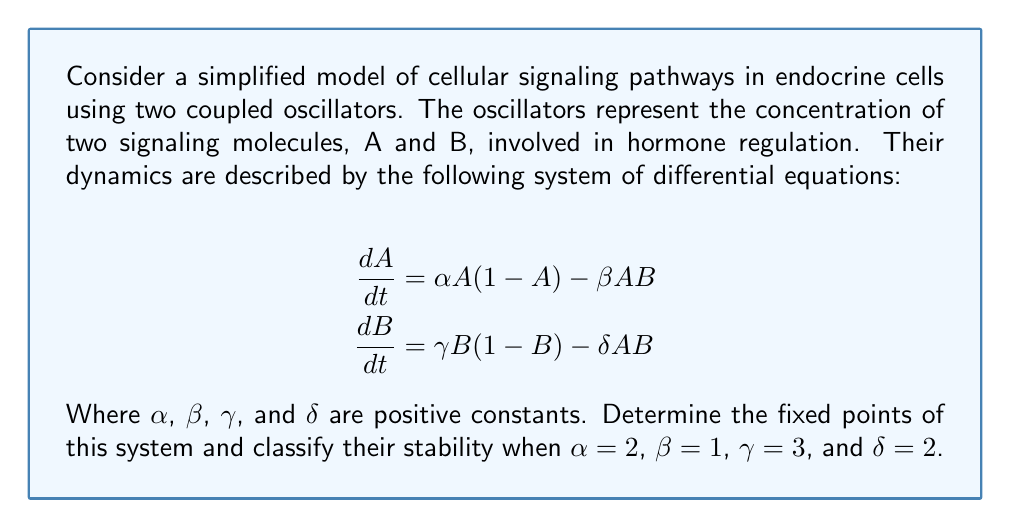Give your solution to this math problem. To solve this problem, we'll follow these steps:

1) Find the fixed points by setting $\frac{dA}{dt} = 0$ and $\frac{dB}{dt} = 0$.

2) Compute the Jacobian matrix at each fixed point.

3) Evaluate the eigenvalues of the Jacobian at each fixed point to determine stability.

Step 1: Finding fixed points

Setting $\frac{dA}{dt} = 0$ and $\frac{dB}{dt} = 0$:

$$0 = \alpha A(1-A) - \beta AB$$
$$0 = \gamma B(1-B) - \delta AB$$

From these equations, we can see that $(0,0)$ is always a fixed point. For other fixed points:

From the first equation: $A = 0$ or $1-A = \frac{\beta B}{\alpha}$
From the second equation: $B = 0$ or $1-B = \frac{\delta A}{\gamma}$

Substituting the given values:

$$1-A = \frac{B}{2}$$
$$1-B = \frac{2A}{3}$$

Solving these simultaneously:

$$A = 1 - \frac{B}{2}$$
$$B = 1 - \frac{2}{3}(1-\frac{B}{2}) = \frac{1}{3} + \frac{B}{3}$$

Solving for B: $B = \frac{1}{2}$, which gives $A = \frac{3}{4}$

So, the fixed points are $(0,0)$ and $(\frac{3}{4},\frac{1}{2})$.

Step 2: Computing the Jacobian

The Jacobian matrix is:

$$J = \begin{bmatrix}
\frac{\partial}{\partial A}(\alpha A(1-A) - \beta AB) & \frac{\partial}{\partial B}(\alpha A(1-A) - \beta AB) \\
\frac{\partial}{\partial A}(\gamma B(1-B) - \delta AB) & \frac{\partial}{\partial B}(\gamma B(1-B) - \delta AB)
\end{bmatrix}$$

$$J = \begin{bmatrix}
\alpha(1-2A) - \beta B & -\beta A \\
-\delta B & \gamma(1-2B) - \delta A
\end{bmatrix}$$

Step 3: Evaluating stability

At $(0,0)$:

$$J_{(0,0)} = \begin{bmatrix}
2 & 0 \\
0 & 3
\end{bmatrix}$$

The eigenvalues are 2 and 3, both positive, so $(0,0)$ is an unstable node.

At $(\frac{3}{4},\frac{1}{2})$:

$$J_{(\frac{3}{4},\frac{1}{2})} = \begin{bmatrix}
-\frac{1}{2} - \frac{1}{2} & -\frac{3}{4} \\
-1 & -\frac{3}{2}
\end{bmatrix} = \begin{bmatrix}
-1 & -\frac{3}{4} \\
-1 & -\frac{3}{2}
\end{bmatrix}$$

The characteristic equation is:

$$\lambda^2 + \frac{5}{2}\lambda + \frac{3}{4} = 0$$

The eigenvalues are $\lambda_1 = -2$ and $\lambda_2 = -\frac{1}{2}$, both negative, so $(\frac{3}{4},\frac{1}{2})$ is a stable node.
Answer: Two fixed points: $(0,0)$ (unstable node) and $(\frac{3}{4},\frac{1}{2})$ (stable node). 